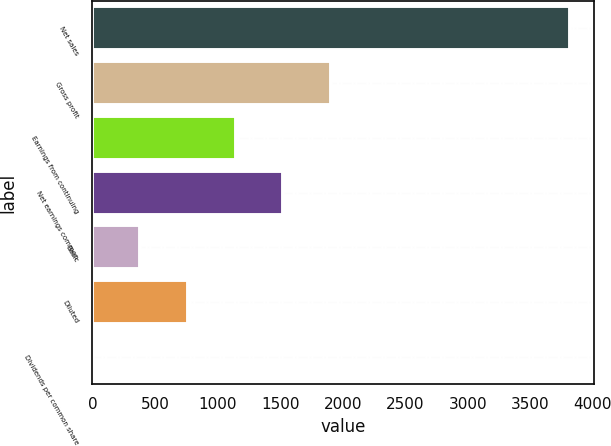Convert chart to OTSL. <chart><loc_0><loc_0><loc_500><loc_500><bar_chart><fcel>Net sales<fcel>Gross profit<fcel>Earnings from continuing<fcel>Net earnings common<fcel>Basic<fcel>Diluted<fcel>Dividends per common share<nl><fcel>3816<fcel>1908.23<fcel>1145.13<fcel>1526.68<fcel>382.03<fcel>763.58<fcel>0.48<nl></chart> 